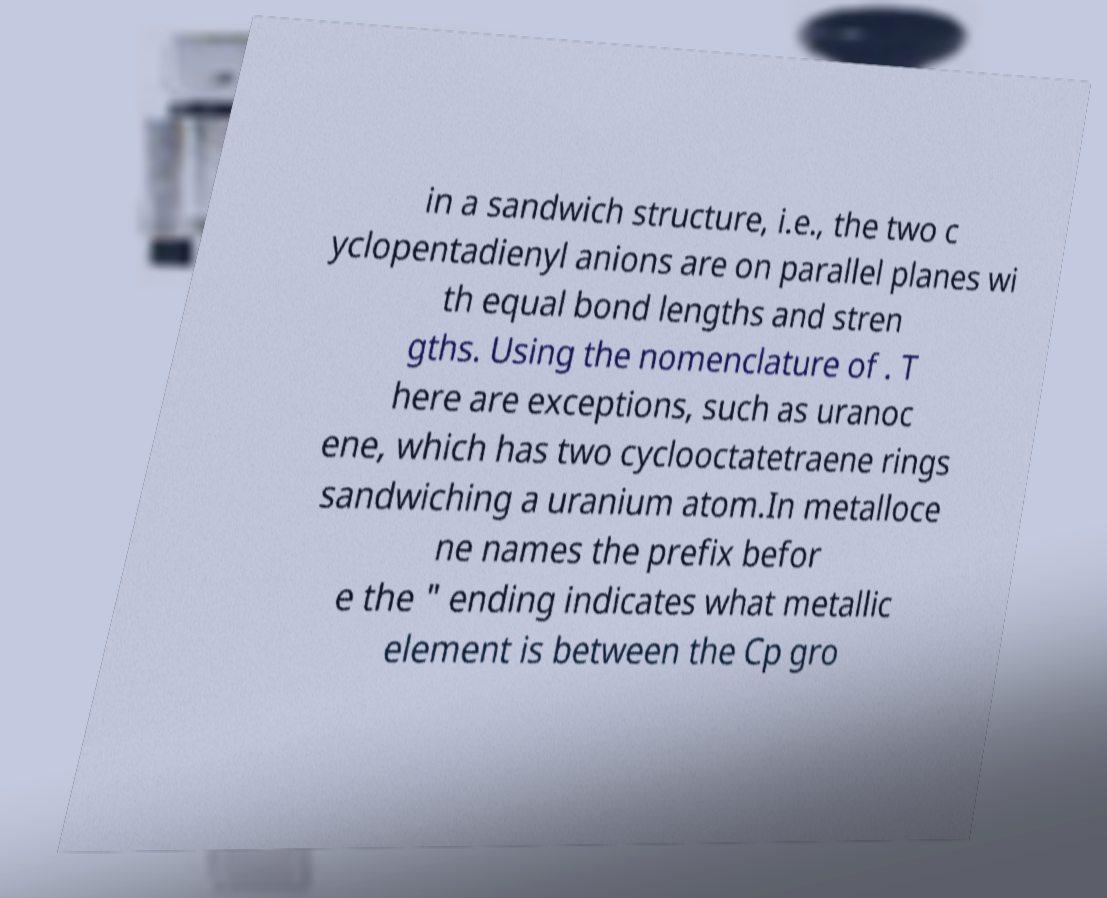Please read and relay the text visible in this image. What does it say? in a sandwich structure, i.e., the two c yclopentadienyl anions are on parallel planes wi th equal bond lengths and stren gths. Using the nomenclature of . T here are exceptions, such as uranoc ene, which has two cyclooctatetraene rings sandwiching a uranium atom.In metalloce ne names the prefix befor e the " ending indicates what metallic element is between the Cp gro 